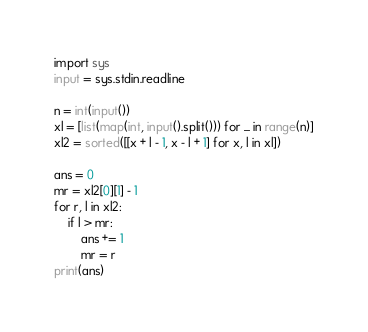Convert code to text. <code><loc_0><loc_0><loc_500><loc_500><_Python_>import sys
input = sys.stdin.readline

n = int(input())
xl = [list(map(int, input().split())) for _ in range(n)]
xl2 = sorted([[x + l - 1, x - l + 1] for x, l in xl])

ans = 0
mr = xl2[0][1] - 1
for r, l in xl2:
    if l > mr:
        ans += 1
        mr = r
print(ans)
</code> 